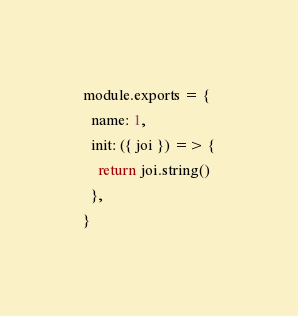Convert code to text. <code><loc_0><loc_0><loc_500><loc_500><_JavaScript_>module.exports = {
  name: 1,
  init: ({ joi }) => {
    return joi.string()
  },
}
</code> 